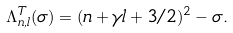<formula> <loc_0><loc_0><loc_500><loc_500>\Lambda ^ { T } _ { n , l } ( \sigma ) = ( n + \gamma l + 3 / 2 ) ^ { 2 } - \sigma .</formula> 